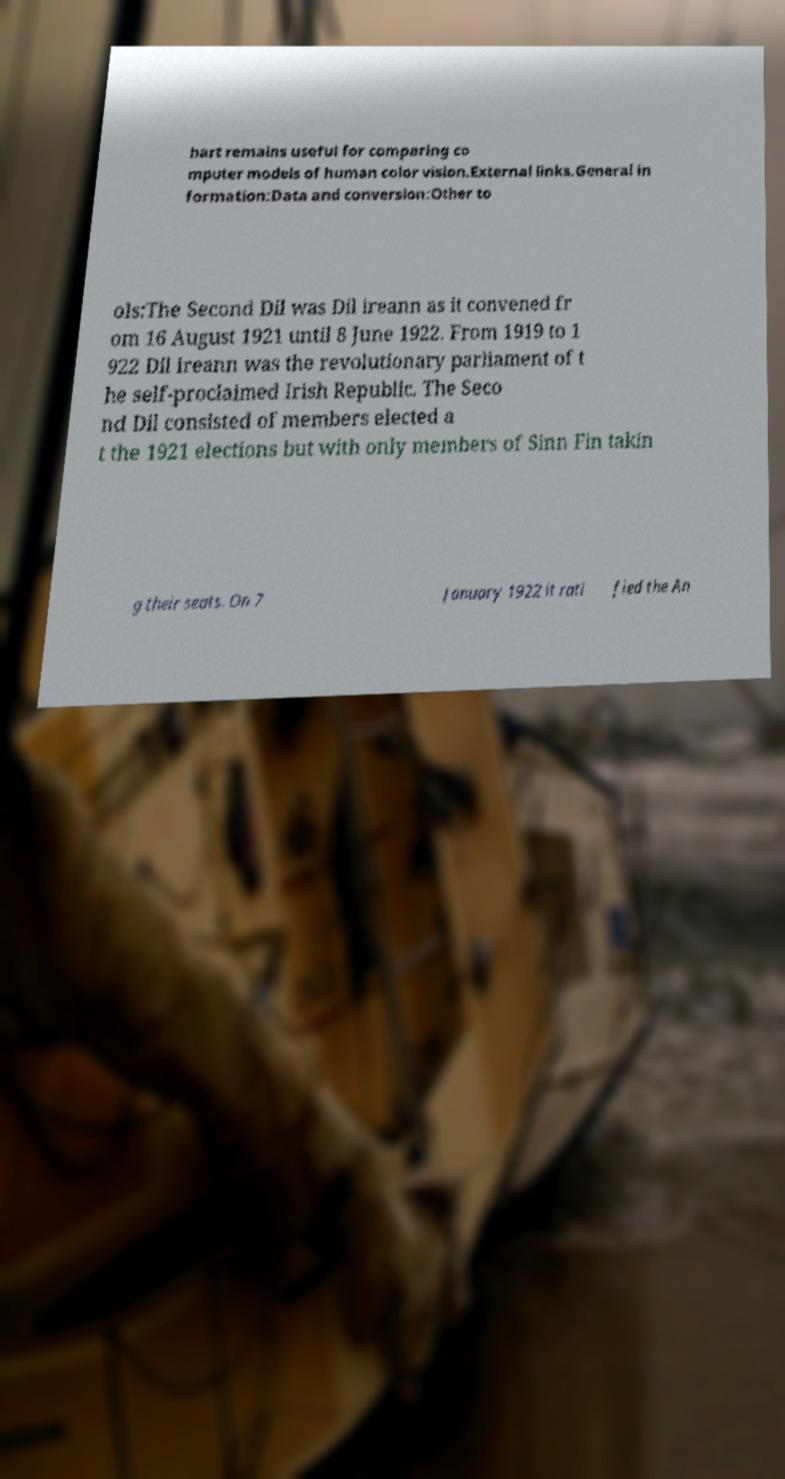Can you read and provide the text displayed in the image?This photo seems to have some interesting text. Can you extract and type it out for me? hart remains useful for comparing co mputer models of human color vision.External links.General in formation:Data and conversion:Other to ols:The Second Dil was Dil ireann as it convened fr om 16 August 1921 until 8 June 1922. From 1919 to 1 922 Dil ireann was the revolutionary parliament of t he self-proclaimed Irish Republic. The Seco nd Dil consisted of members elected a t the 1921 elections but with only members of Sinn Fin takin g their seats. On 7 January 1922 it rati fied the An 